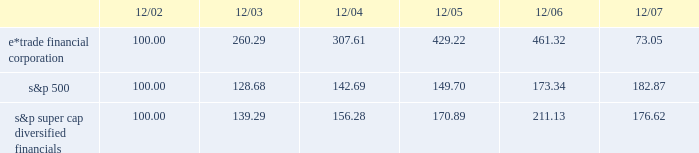December 18 , 2007 , we issued an additional 23182197 shares of common stock to citadel .
The issuances were exempt from registration pursuant to section 4 ( 2 ) of the securities act of 1933 , and each purchaser has represented to us that it is an 201caccredited investor 201d as defined in regulation d promulgated under the securities act of 1933 , and that the common stock was being acquired for investment .
We did not engage in a general solicitation or advertising with regard to the issuances of the common stock and have not offered securities to the public in connection with the issuances .
See item 1 .
Business 2014citadel investment .
Performance graph the following performance graph shows the cumulative total return to a holder of the company 2019s common stock , assuming dividend reinvestment , compared with the cumulative total return , assuming dividend reinvestment , of the standard & poor 2019s ( 201cs&p 201d ) 500 and the s&p super cap diversified financials during the period from december 31 , 2002 through december 31 , 2007. .
2022 $ 100 invested on 12/31/02 in stock or index-including reinvestment of dividends .
Fiscal year ending december 31 .
2022 copyright a9 2008 , standard & poor 2019s , a division of the mcgraw-hill companies , inc .
All rights reserved .
Www.researchdatagroup.com/s&p.htm .
What was the percentage cumulative total return for e*trade financial corporation for the five years ended 12/07? 
Computations: ((73.05 - 100) / 100)
Answer: -0.2695. 